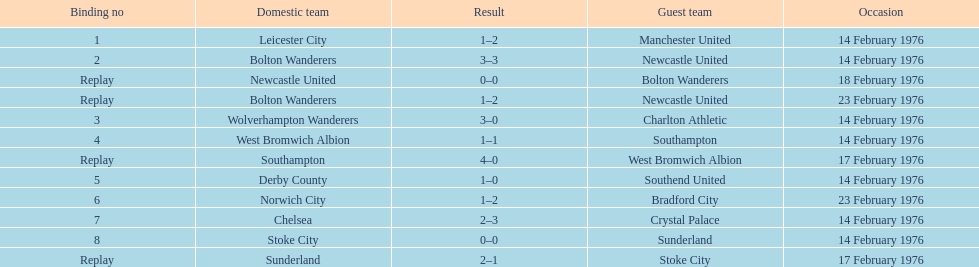How many games did the bolton wanderers and newcastle united play before there was a definitive winner in the fifth round proper? 3. 